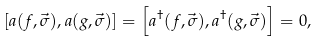<formula> <loc_0><loc_0><loc_500><loc_500>\left [ a ( f , \vec { \sigma } ) , a ( g , \vec { \sigma } ) \right ] = \left [ a ^ { \dagger } ( f , \vec { \sigma } ) , a ^ { \dagger } ( g , \vec { \sigma } ) \right ] = 0 ,</formula> 